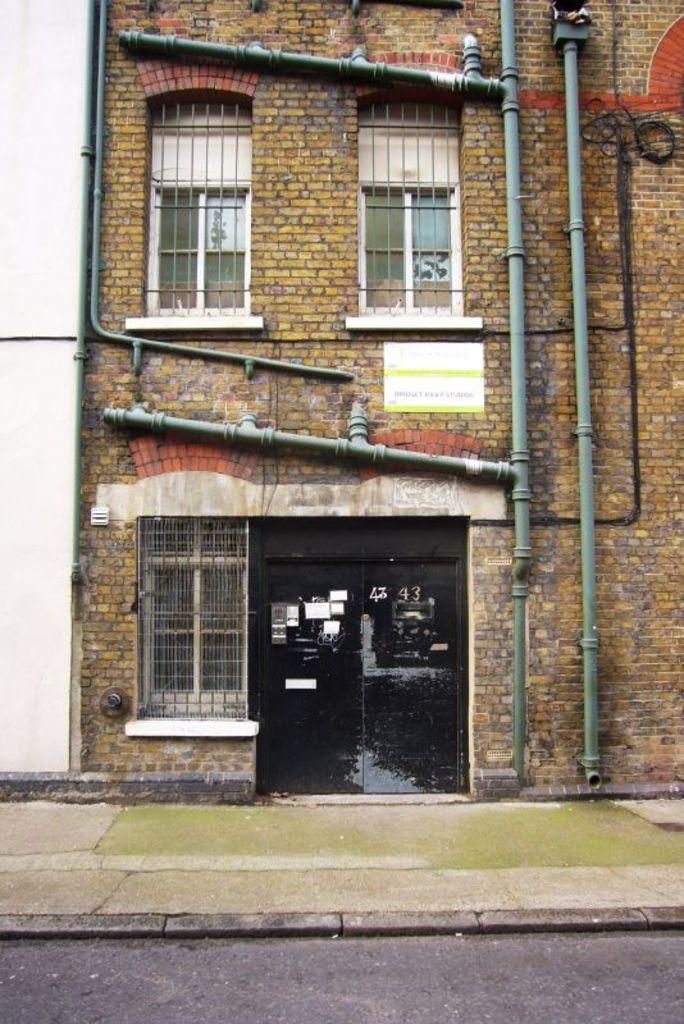What type of structure is visible in the image? There is a building in the image. What feature can be seen on the building? The building has windows. Are there any additional elements attached to the building? Yes, there are pipes attached to the wall of the building. How can someone enter the building in the image? There are two glass doors in the image. What is visible at the bottom of the image? There is a road at the bottom of the image. What type of stew is being cooked in the building in the image? There is no indication of any cooking or stew in the image; it only shows a building with windows, pipes, and doors. How many chickens can be seen in the image? There are no chickens present in the image. 